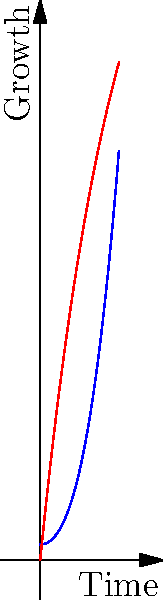The blue curve represents a polynomial function modeling the growth of a community, while the red curve shows the spread of faith within that community. Based on the graph, at what point in time does the spread of faith surpass the community growth, symbolizing the moment when spiritual growth becomes more significant than numerical growth? To solve this problem, we need to follow these steps:

1. Observe the graph carefully, noting the behavior of both curves.
2. Identify the point where the red curve (faith growth) intersects with the blue curve (community growth).
3. Estimate the x-coordinate (time) of this intersection point.

Looking at the graph:

1. The blue curve (polynomial function) starts higher but grows more slowly at first, then accelerates.
2. The red curve (faith growth) starts lower but grows rapidly at first, then slows down.
3. The two curves intersect at approximately x = 2.5 on the time axis.

This intersection point represents the moment when the spread of faith surpasses the community growth. Before this point, the community was growing faster than faith was spreading. After this point, faith spreads more extensively than the community grows.

In the context of our faith-based interpretation, this could symbolize the moment when the spiritual growth within the community becomes more significant than its numerical growth, potentially indicating a tipping point in the community's spiritual journey.
Answer: Approximately 2.5 time units 